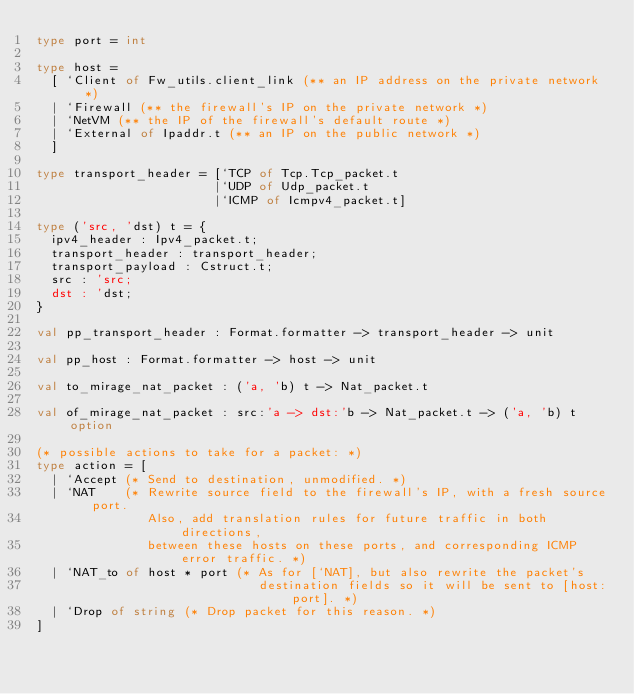Convert code to text. <code><loc_0><loc_0><loc_500><loc_500><_OCaml_>type port = int

type host =
  [ `Client of Fw_utils.client_link (** an IP address on the private network *)
  | `Firewall (** the firewall's IP on the private network *)
  | `NetVM (** the IP of the firewall's default route *)
  | `External of Ipaddr.t (** an IP on the public network *)
  ]

type transport_header = [`TCP of Tcp.Tcp_packet.t
                        |`UDP of Udp_packet.t
                        |`ICMP of Icmpv4_packet.t]

type ('src, 'dst) t = {
  ipv4_header : Ipv4_packet.t;
  transport_header : transport_header;
  transport_payload : Cstruct.t;
  src : 'src;
  dst : 'dst;
}

val pp_transport_header : Format.formatter -> transport_header -> unit

val pp_host : Format.formatter -> host -> unit

val to_mirage_nat_packet : ('a, 'b) t -> Nat_packet.t

val of_mirage_nat_packet : src:'a -> dst:'b -> Nat_packet.t -> ('a, 'b) t option

(* possible actions to take for a packet: *)
type action = [
  | `Accept (* Send to destination, unmodified. *)
  | `NAT    (* Rewrite source field to the firewall's IP, with a fresh source port.
               Also, add translation rules for future traffic in both directions,
               between these hosts on these ports, and corresponding ICMP error traffic. *)
  | `NAT_to of host * port (* As for [`NAT], but also rewrite the packet's
                              destination fields so it will be sent to [host:port]. *)
  | `Drop of string (* Drop packet for this reason. *)
]
</code> 